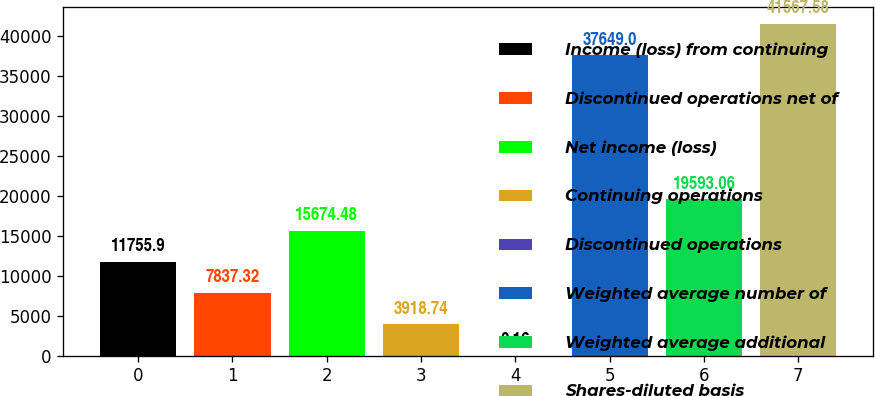Convert chart to OTSL. <chart><loc_0><loc_0><loc_500><loc_500><bar_chart><fcel>Income (loss) from continuing<fcel>Discontinued operations net of<fcel>Net income (loss)<fcel>Continuing operations<fcel>Discontinued operations<fcel>Weighted average number of<fcel>Weighted average additional<fcel>Shares-diluted basis<nl><fcel>11755.9<fcel>7837.32<fcel>15674.5<fcel>3918.74<fcel>0.16<fcel>37649<fcel>19593.1<fcel>41567.6<nl></chart> 